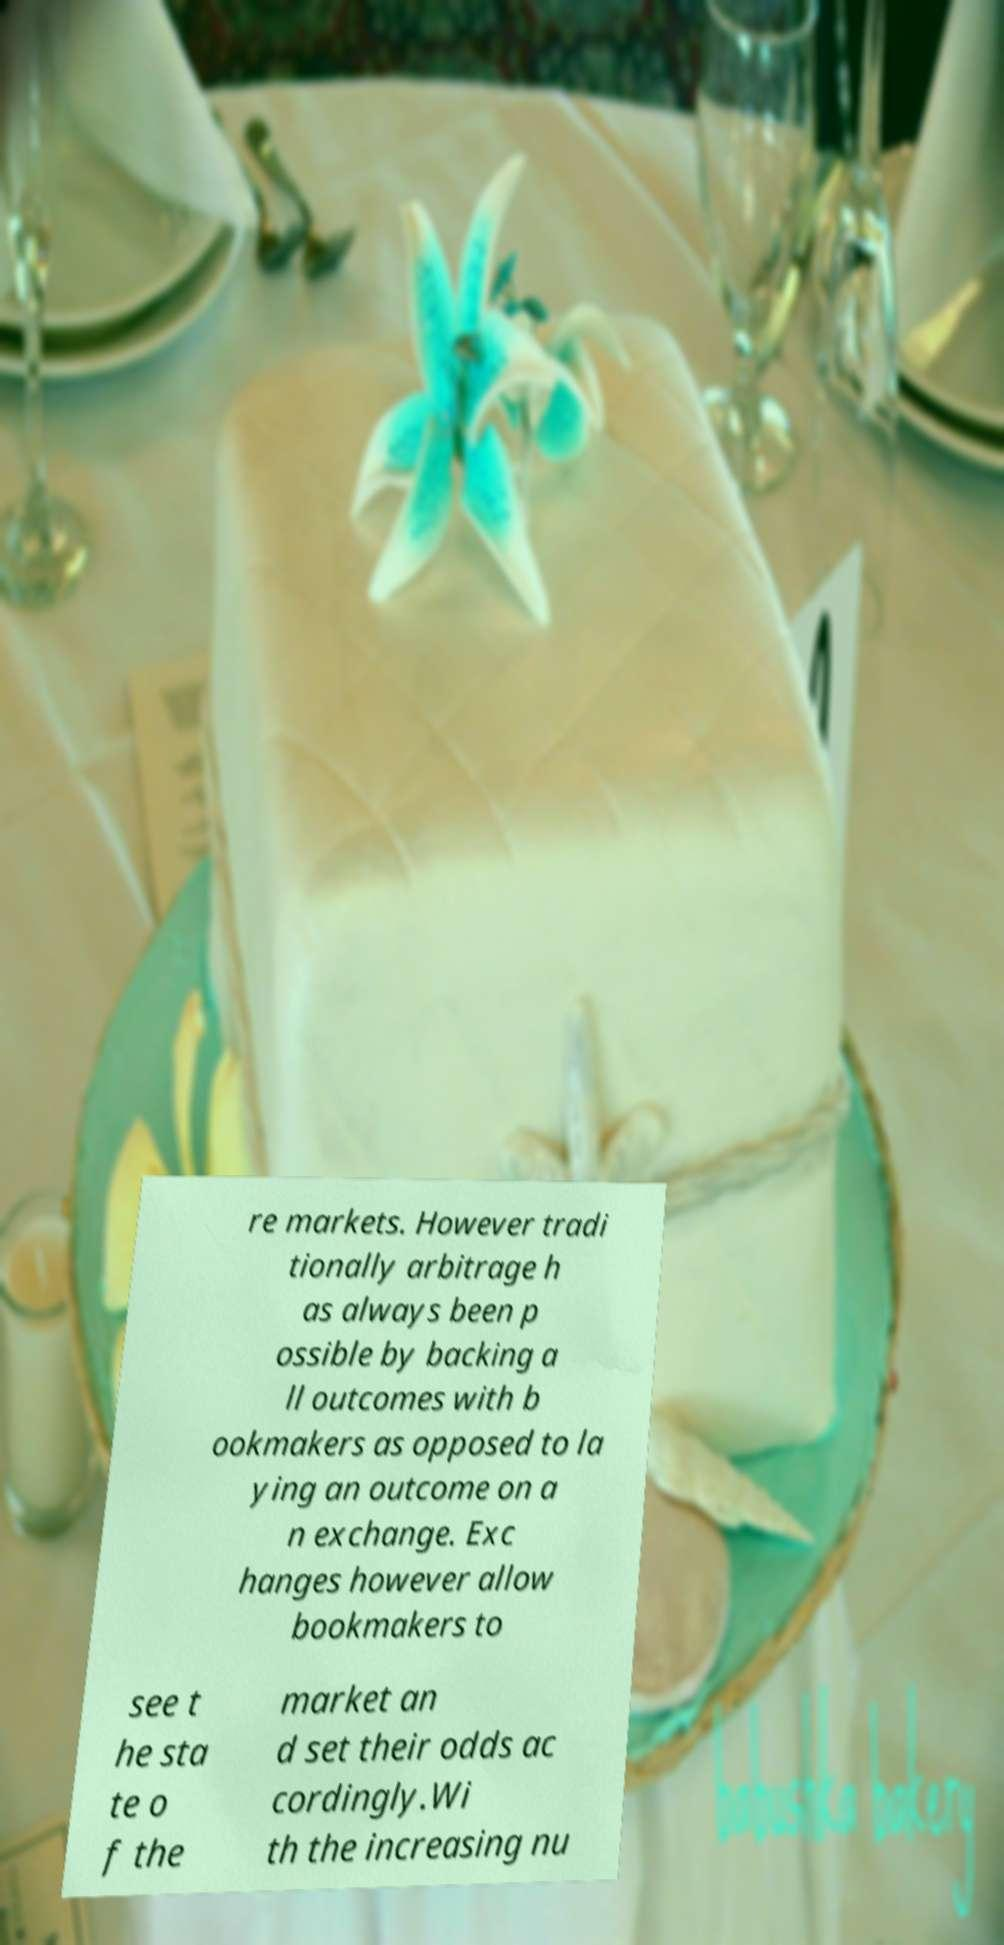Please identify and transcribe the text found in this image. re markets. However tradi tionally arbitrage h as always been p ossible by backing a ll outcomes with b ookmakers as opposed to la ying an outcome on a n exchange. Exc hanges however allow bookmakers to see t he sta te o f the market an d set their odds ac cordingly.Wi th the increasing nu 